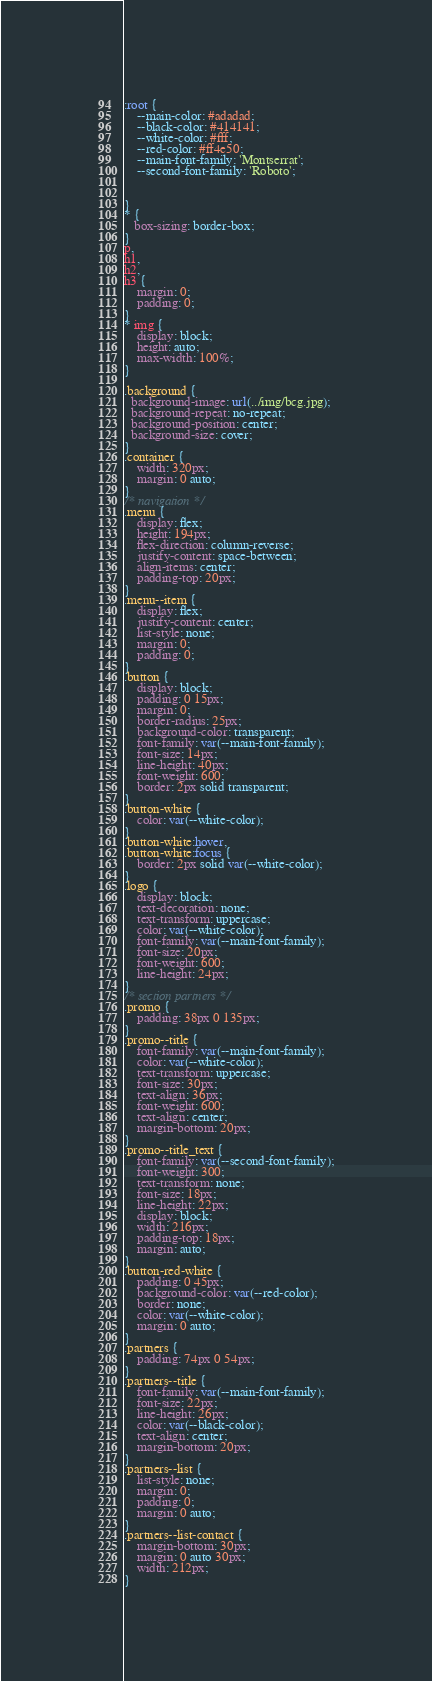<code> <loc_0><loc_0><loc_500><loc_500><_CSS_>:root {
    --main-color: #adadad;
    --black-color: #414141;
    --white-color: #fff;
    --red-color: #ff4e50;
    --main-font-family: 'Montserrat';
    --second-font-family: 'Roboto';


}
* {
   box-sizing: border-box; 
}
p,
h1,
h2,
h3 {
    margin: 0;
    padding: 0;
}
* img {
    display: block;
    height: auto;
    max-width: 100%;
}

.background {
  background-image: url(../img/bcg.jpg);
  background-repeat: no-repeat;
  background-position: center;
  background-size: cover;
}
.container {
    width: 320px;
    margin: 0 auto;
}
/* navigation */
.menu {
    display: flex;
    height: 194px;
    flex-direction: column-reverse;
    justify-content: space-between;
    align-items: center;
    padding-top: 20px;
}
.menu--item {
    display: flex;
    justify-content: center;
    list-style: none;
    margin: 0;
    padding: 0;
}
.button {
    display: block;
    padding: 0 15px;
    margin: 0;
    border-radius: 25px;
    background-color: transparent;
    font-family: var(--main-font-family);
    font-size: 14px;
    line-height: 40px;
    font-weight: 600;
    border: 2px solid transparent;
}
.button-white {
    color: var(--white-color);
}
.button-white:hover,
.button-white:focus {
    border: 2px solid var(--white-color);
}
.logo {
    display: block;
    text-decoration: none;
    text-transform: uppercase;
    color: var(--white-color);
    font-family: var(--main-font-family);
    font-size: 20px;
    font-weight: 600;
    line-height: 24px;
}
/* section partners */
.promo {
    padding: 38px 0 135px;
}
.promo--title {
    font-family: var(--main-font-family);
    color: var(--white-color);
    text-transform: uppercase;
    font-size: 30px;
    text-align: 36px;
    font-weight: 600;
    text-align: center;
    margin-bottom: 20px;
}
.promo--title_text {
    font-family: var(--second-font-family);
    font-weight: 300;
    text-transform: none;
    font-size: 18px;
    line-height: 22px;
    display: block;
    width: 216px;
    padding-top: 18px;
    margin: auto;
}
.button-red-white {
    padding: 0 45px;
    background-color: var(--red-color);
    border: none;
    color: var(--white-color);
    margin: 0 auto;
}
.partners {
    padding: 74px 0 54px;
}
.partners--title {
    font-family: var(--main-font-family);
    font-size: 22px;
    line-height: 26px;
    color: var(--black-color);
    text-align: center;
    margin-bottom: 20px;
}
.partners--list {
    list-style: none;
    margin: 0;
    padding: 0;
    margin: 0 auto;
}
.partners--list-contact {
    margin-bottom: 30px;
    margin: 0 auto 30px;
    width: 212px;
}</code> 